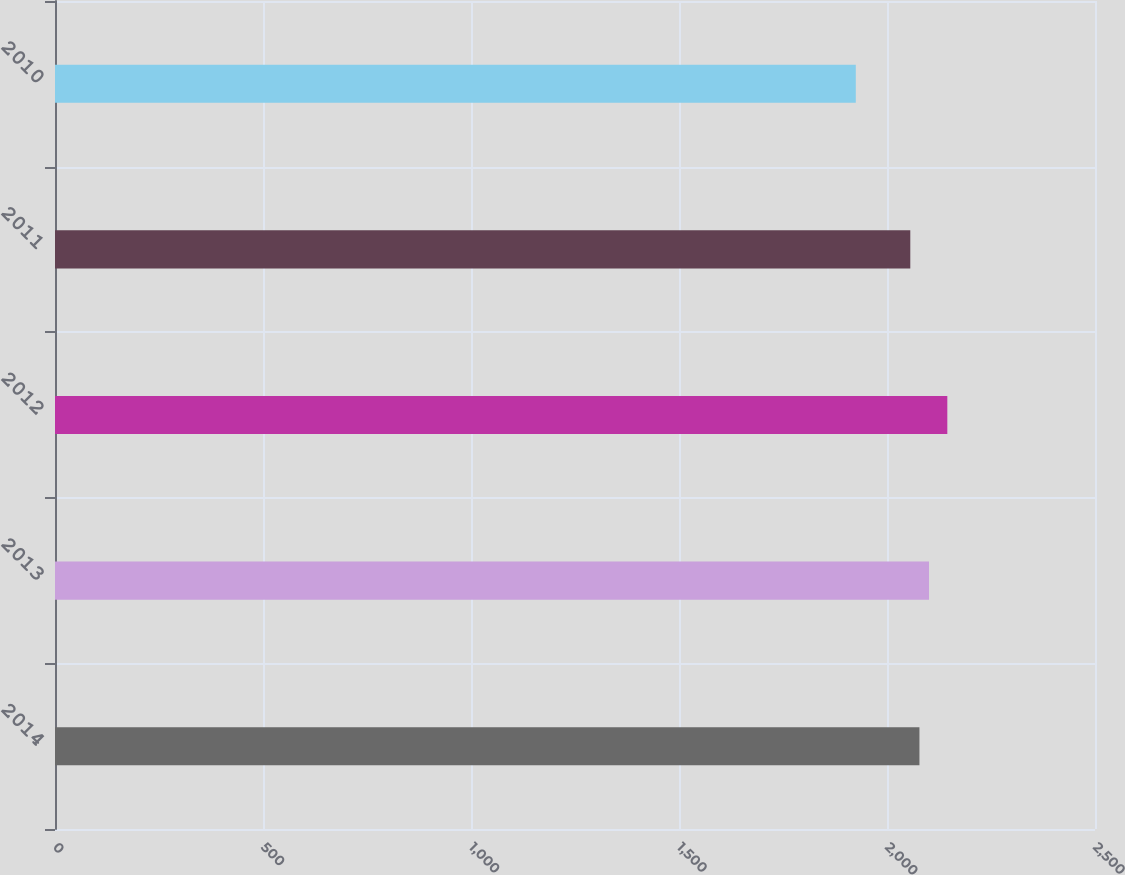Convert chart to OTSL. <chart><loc_0><loc_0><loc_500><loc_500><bar_chart><fcel>2014<fcel>2013<fcel>2012<fcel>2011<fcel>2010<nl><fcel>2078<fcel>2101<fcel>2145<fcel>2056<fcel>1925<nl></chart> 